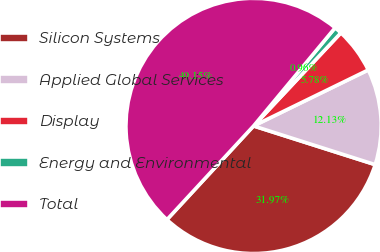Convert chart to OTSL. <chart><loc_0><loc_0><loc_500><loc_500><pie_chart><fcel>Silicon Systems<fcel>Applied Global Services<fcel>Display<fcel>Energy and Environmental<fcel>Total<nl><fcel>31.97%<fcel>12.13%<fcel>5.78%<fcel>0.96%<fcel>49.15%<nl></chart> 